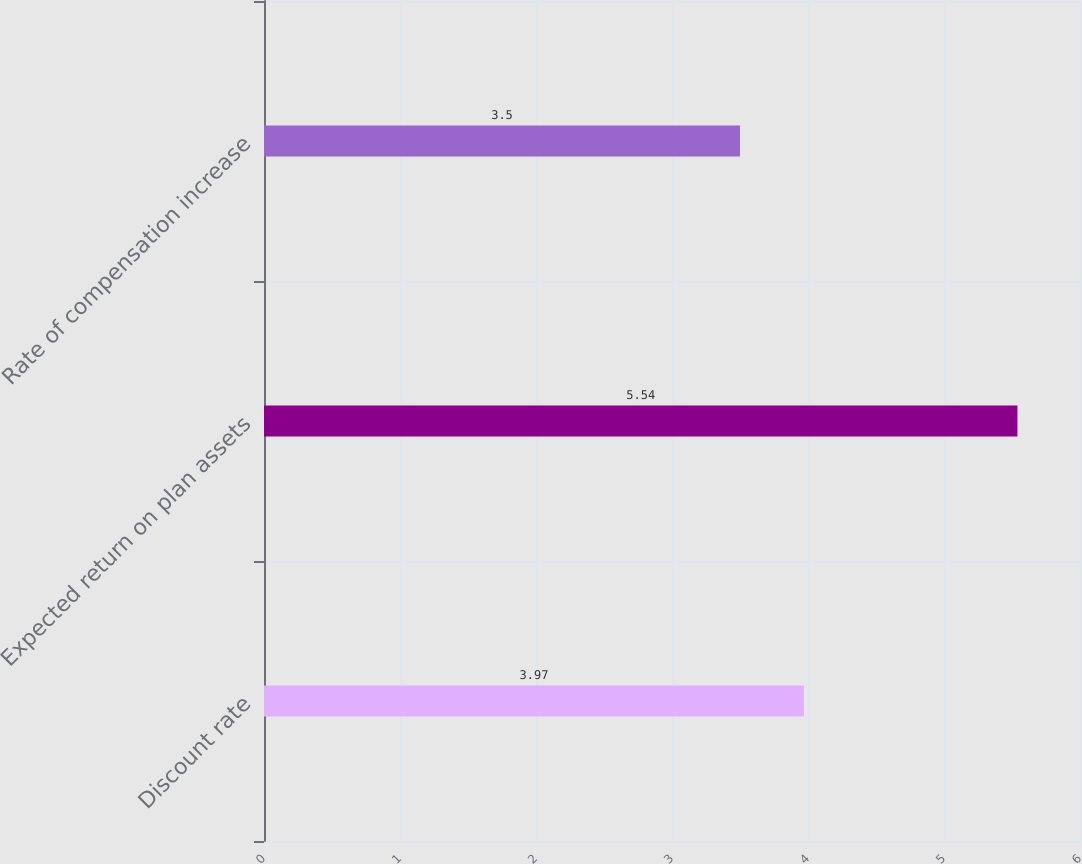Convert chart to OTSL. <chart><loc_0><loc_0><loc_500><loc_500><bar_chart><fcel>Discount rate<fcel>Expected return on plan assets<fcel>Rate of compensation increase<nl><fcel>3.97<fcel>5.54<fcel>3.5<nl></chart> 